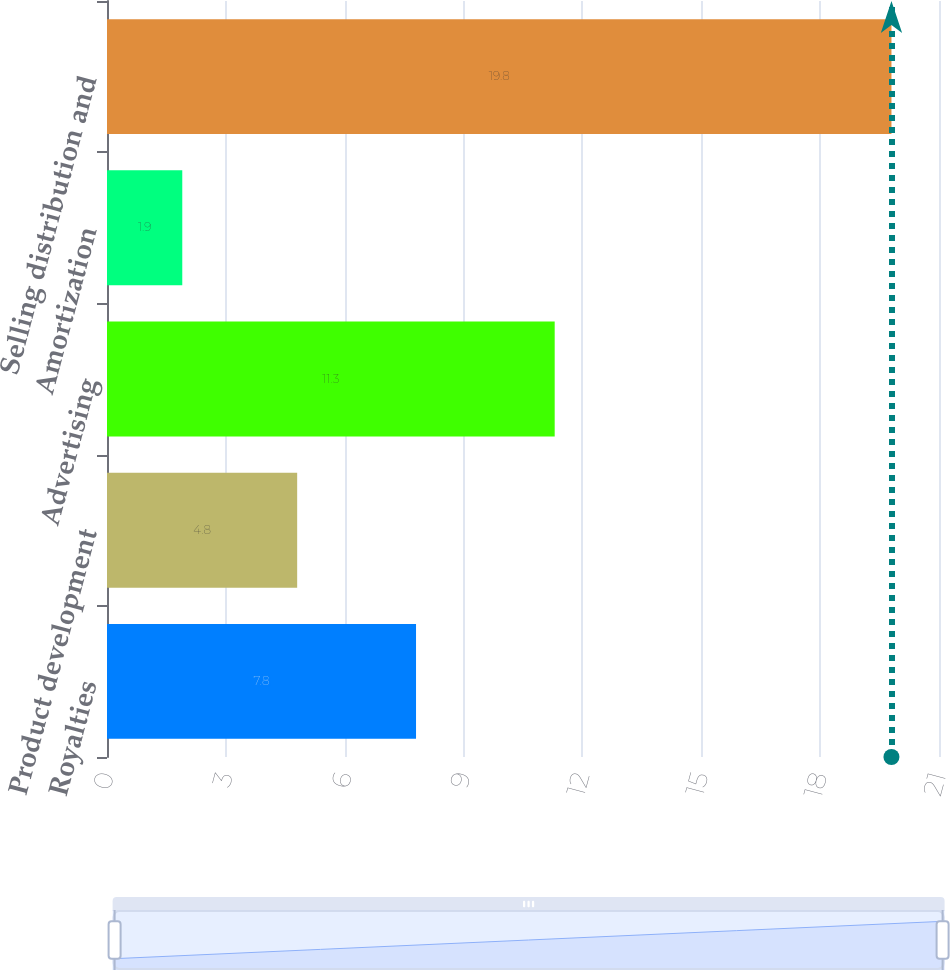<chart> <loc_0><loc_0><loc_500><loc_500><bar_chart><fcel>Royalties<fcel>Product development<fcel>Advertising<fcel>Amortization<fcel>Selling distribution and<nl><fcel>7.8<fcel>4.8<fcel>11.3<fcel>1.9<fcel>19.8<nl></chart> 